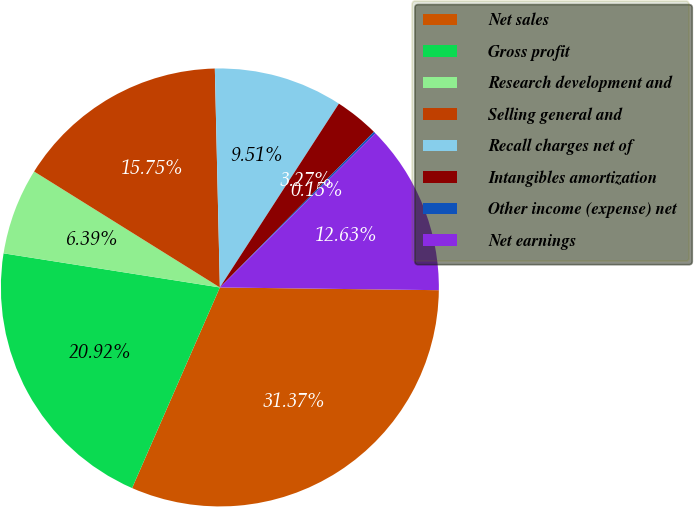<chart> <loc_0><loc_0><loc_500><loc_500><pie_chart><fcel>Net sales<fcel>Gross profit<fcel>Research development and<fcel>Selling general and<fcel>Recall charges net of<fcel>Intangibles amortization<fcel>Other income (expense) net<fcel>Net earnings<nl><fcel>31.36%<fcel>20.92%<fcel>6.39%<fcel>15.75%<fcel>9.51%<fcel>3.27%<fcel>0.15%<fcel>12.63%<nl></chart> 